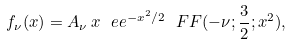<formula> <loc_0><loc_0><loc_500><loc_500>f _ { \nu } ( x ) = A _ { \nu } \, x \ e e ^ { - x ^ { 2 } / 2 } \ F F ( - \nu ; \frac { 3 } { 2 } ; x ^ { 2 } ) ,</formula> 